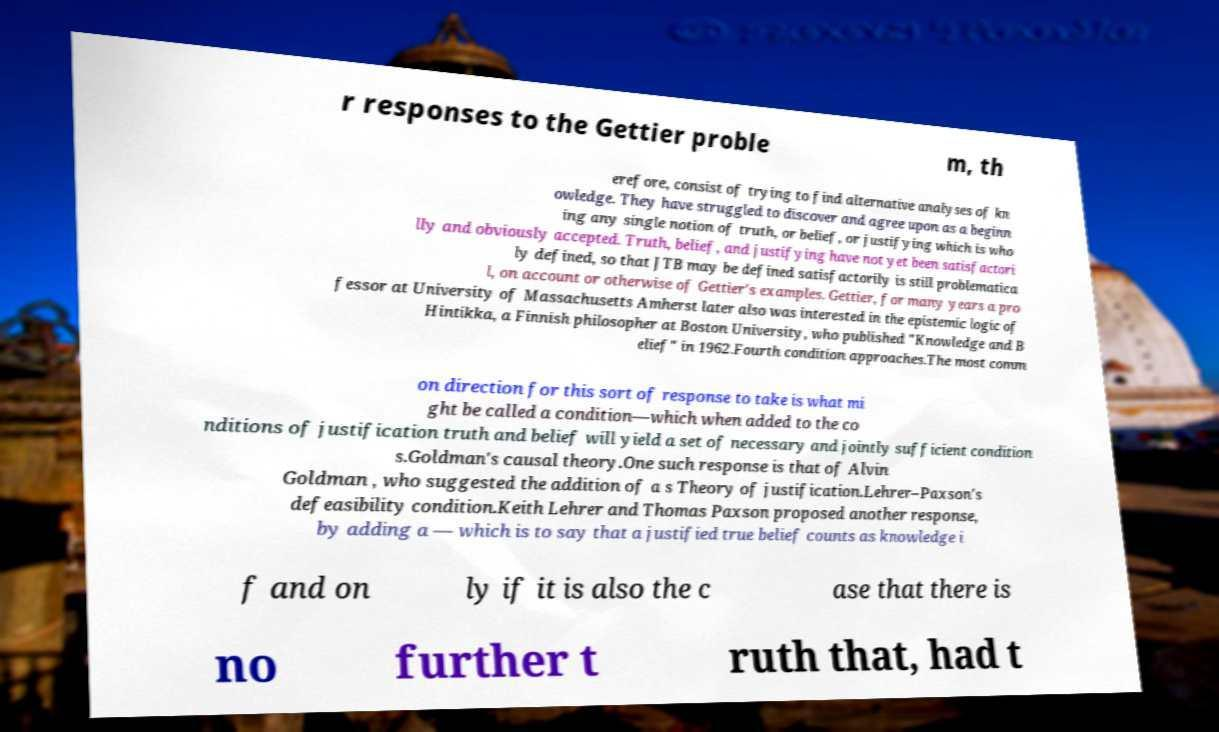What messages or text are displayed in this image? I need them in a readable, typed format. r responses to the Gettier proble m, th erefore, consist of trying to find alternative analyses of kn owledge. They have struggled to discover and agree upon as a beginn ing any single notion of truth, or belief, or justifying which is who lly and obviously accepted. Truth, belief, and justifying have not yet been satisfactori ly defined, so that JTB may be defined satisfactorily is still problematica l, on account or otherwise of Gettier's examples. Gettier, for many years a pro fessor at University of Massachusetts Amherst later also was interested in the epistemic logic of Hintikka, a Finnish philosopher at Boston University, who published "Knowledge and B elief" in 1962.Fourth condition approaches.The most comm on direction for this sort of response to take is what mi ght be called a condition—which when added to the co nditions of justification truth and belief will yield a set of necessary and jointly sufficient condition s.Goldman's causal theory.One such response is that of Alvin Goldman , who suggested the addition of a s Theory of justification.Lehrer–Paxson's defeasibility condition.Keith Lehrer and Thomas Paxson proposed another response, by adding a — which is to say that a justified true belief counts as knowledge i f and on ly if it is also the c ase that there is no further t ruth that, had t 